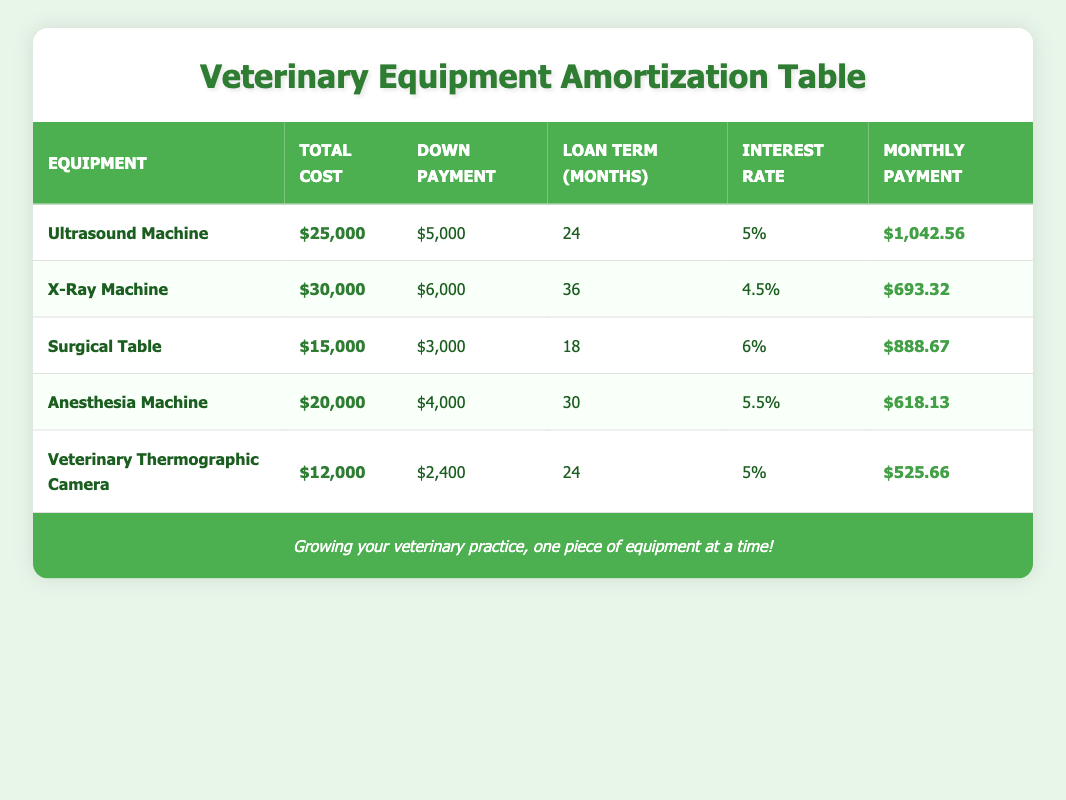What is the total cost of the Ultrasound Machine? The table shows the total cost for the Ultrasound Machine listed as $25,000.
Answer: $25,000 How much is the down payment for the Anesthesia Machine? The table indicates that the down payment for the Anesthesia Machine is $4,000.
Answer: $4,000 Which equipment has the longest loan term? By comparing the loan terms in the table, the X-Ray Machine has a loan term of 36 months, which is the longest among the listed equipment.
Answer: X-Ray Machine What is the average monthly payment for all equipment? To find the average monthly payment, we sum the monthly payments ($1,042.56 + $693.32 + $888.67 + $618.13 + $525.66 = $3,768.34) and divide by the number of equipment (5), resulting in an average of $3,768.34 / 5 = $753.67.
Answer: $753.67 Is the monthly payment for the Surgical Table higher than the Veterinary Thermographic Camera? The monthly payment for the Surgical Table is $888.67, while the Veterinary Thermographic Camera's payment is $525.66. Since $888.67 is greater than $525.66, the statement is true.
Answer: Yes Which equipment has the lowest interest rate and what is that rate? By reviewing the interest rates, the X-Ray Machine has the lowest interest rate of 4.5%.
Answer: 4.5% What is the difference between the total cost of the Ultrasound Machine and the Surgical Table? The difference is calculated by subtracting the total cost of the Surgical Table ($15,000) from that of the Ultrasound Machine ($25,000): $25,000 - $15,000 = $10,000.
Answer: $10,000 How many pieces of equipment have a monthly payment less than $700? The X-Ray Machine has a monthly payment of $693.32 and the Anesthesia Machine has a payment of $618.13. Since both are below $700, there are 2 pieces of equipment that meet this criterion.
Answer: 2 Is any equipment’s down payment equal to $2,400? The table shows that the down payment of the Veterinary Thermographic Camera is exactly $2,400, making this statement true.
Answer: Yes 